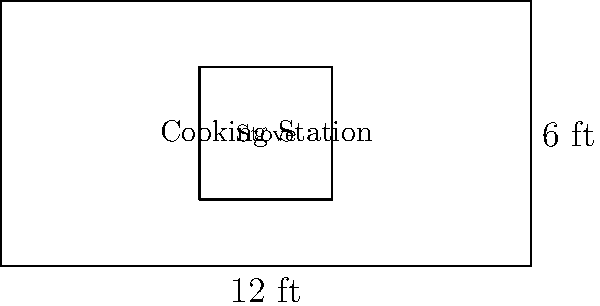For the upcoming Caribbean cooking class, you're setting up a rectangular cooking station. The station measures 12 feet in length and 6 feet in width. What is the perimeter of this cooking station? To find the perimeter of a rectangle, we need to add up the lengths of all four sides. Let's break it down step-by-step:

1. Identify the length and width:
   Length (l) = 12 feet
   Width (w) = 6 feet

2. The formula for the perimeter of a rectangle is:
   $$P = 2l + 2w$$
   Where P is the perimeter, l is the length, and w is the width.

3. Substitute the values into the formula:
   $$P = 2(12) + 2(6)$$

4. Calculate:
   $$P = 24 + 12 = 36$$

Therefore, the perimeter of the cooking station is 36 feet.
Answer: 36 feet 